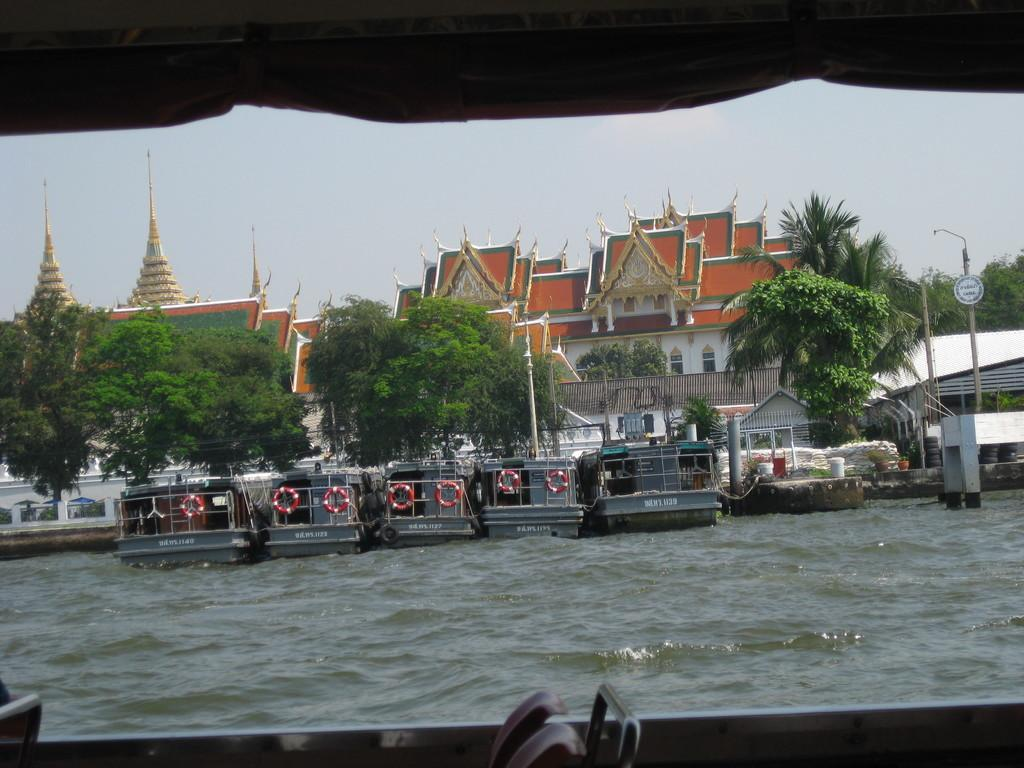What is the vantage point of the image? The image is taken from a boat. What can be seen on the water in the image? There are other boats floating on the water in the image. What type of natural scenery is visible in the background of the image? Trees are visible in the background of the image. What type of man-made structures are visible in the background of the image? Buildings are present in the background of the image. What type of vertical structures are visible in the background of the image? Poles are observable in the background of the image. What part of the sky is visible in the image? The sky is visible in the background of the image. What time of day is it in the image, based on the presence of morning dew on the sticks? There are no sticks or morning dew mentioned in the image, so it is not possible to determine the time of day based on that information. 